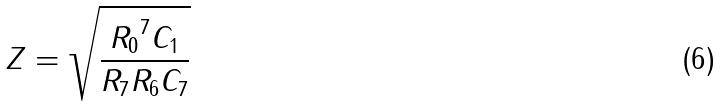Convert formula to latex. <formula><loc_0><loc_0><loc_500><loc_500>Z = \sqrt { \frac { { R _ { 0 } } ^ { 7 } C _ { 1 } } { R _ { 7 } R _ { 6 } C _ { 7 } } }</formula> 